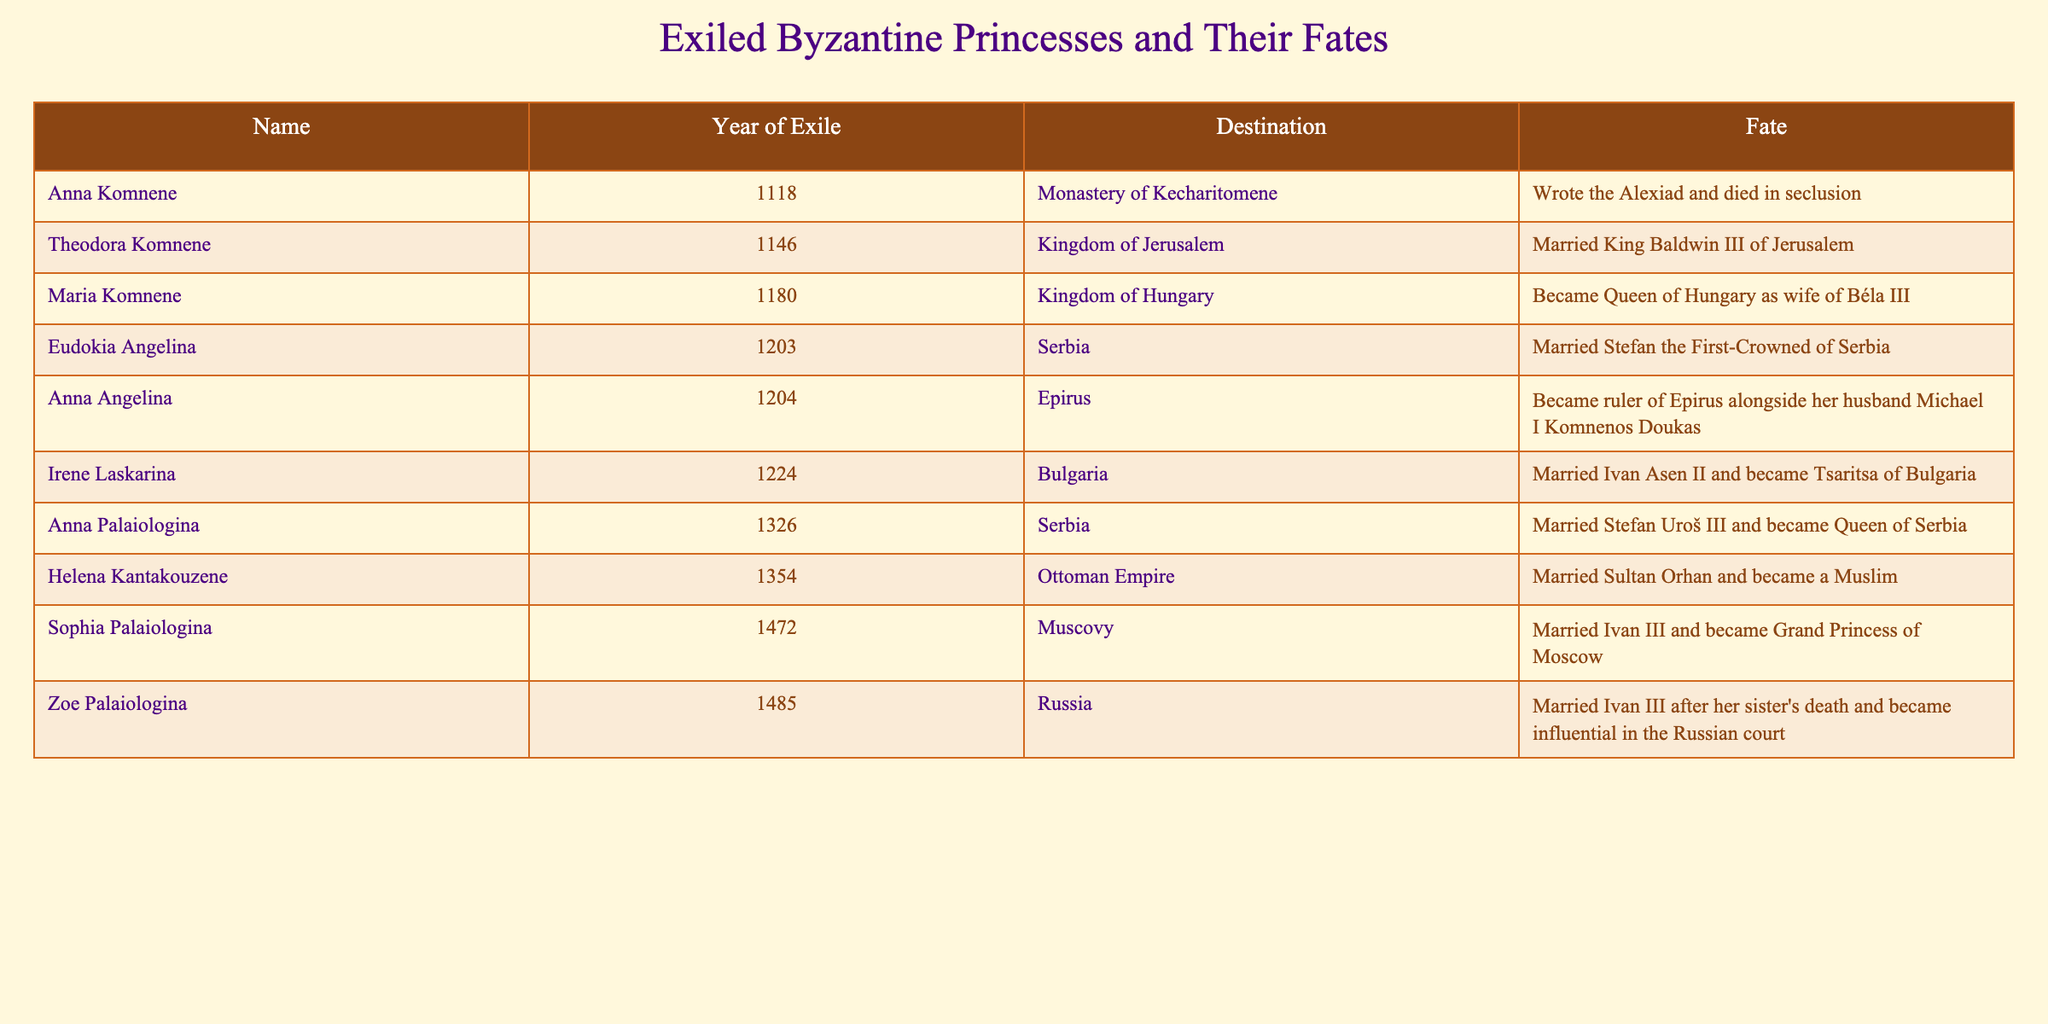What year did Anna Komnene go into exile? The table lists Anna Komnene along with her year of exile, which is 1118.
Answer: 1118 Which princess became Queen of Hungary? The table indicates that Maria Komnene became Queen of Hungary as the wife of Béla III.
Answer: Maria Komnene What destination did Eudokia Angelina reach during her exile? According to the table, Eudokia Angelina was exiled to Serbia.
Answer: Serbia How many princesses were exiled to Serbia? By counting the entries for princesses that list Serbia as their destination, we find two: Eudokia Angelina and Anna Palaiologina.
Answer: 2 Did Anna Angelina rule Epirus? The table states that Anna Angelina became ruler of Epirus alongside her husband, Michael I Komnenos Doukas, confirming she did rule there.
Answer: Yes Which princess was exiled the latest? Looking at the years of exile in the table, Zoe Palaiologina was exiled in 1485, which is the latest year listed.
Answer: Zoe Palaiologina What is the fate of Sophia Palaiologina? The table indicates that Sophia Palaiologina married Ivan III and became Grand Princess of Moscow.
Answer: Grand Princess of Moscow Were any of the princesses married to kings? Reviewing the data in the table, several princesses were married to kings, including Theodora Komnene and Maria Komnene.
Answer: Yes Which two princesses married Serbian rulers? Referring to the table, the two princesses who married Serbian rulers were Eudokia Angelina and Anna Palaiologina.
Answer: Eudokia Angelina and Anna Palaiologina How many princesses became queens as a result of their marriages? The table shows Maria Komnene, Anna Palaiologina, and Helena Kantakouzene became queens through marriage, totaling three.
Answer: 3 